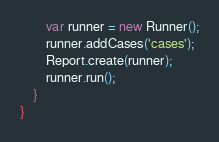<code> <loc_0><loc_0><loc_500><loc_500><_Haxe_>        var runner = new Runner();
        runner.addCases('cases');
        Report.create(runner);
        runner.run();
    }
}
</code> 